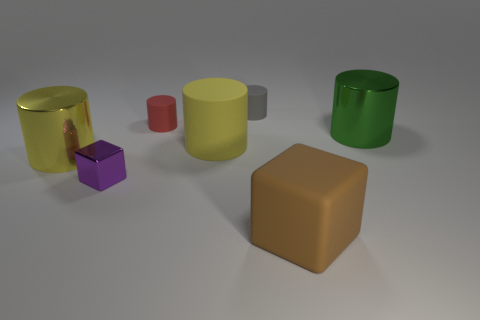Does the large thing that is behind the large rubber cylinder have the same material as the cube to the left of the big brown matte cube?
Give a very brief answer. Yes. What material is the large object that is the same color as the large matte cylinder?
Offer a very short reply. Metal. What number of other tiny purple things are the same shape as the small purple object?
Keep it short and to the point. 0. Is the purple thing made of the same material as the small thing that is behind the tiny red matte cylinder?
Your answer should be compact. No. There is a yellow thing that is the same size as the yellow metallic cylinder; what is it made of?
Provide a short and direct response. Rubber. Are there any brown blocks of the same size as the purple object?
Make the answer very short. No. There is a red thing that is the same size as the purple block; what shape is it?
Keep it short and to the point. Cylinder. What number of other objects are there of the same color as the small metal cube?
Offer a terse response. 0. What is the shape of the rubber object that is both behind the large yellow rubber cylinder and in front of the gray matte cylinder?
Make the answer very short. Cylinder. Are there any small rubber cylinders that are to the left of the large shiny object that is in front of the large metallic object on the right side of the brown matte cube?
Your response must be concise. No. 